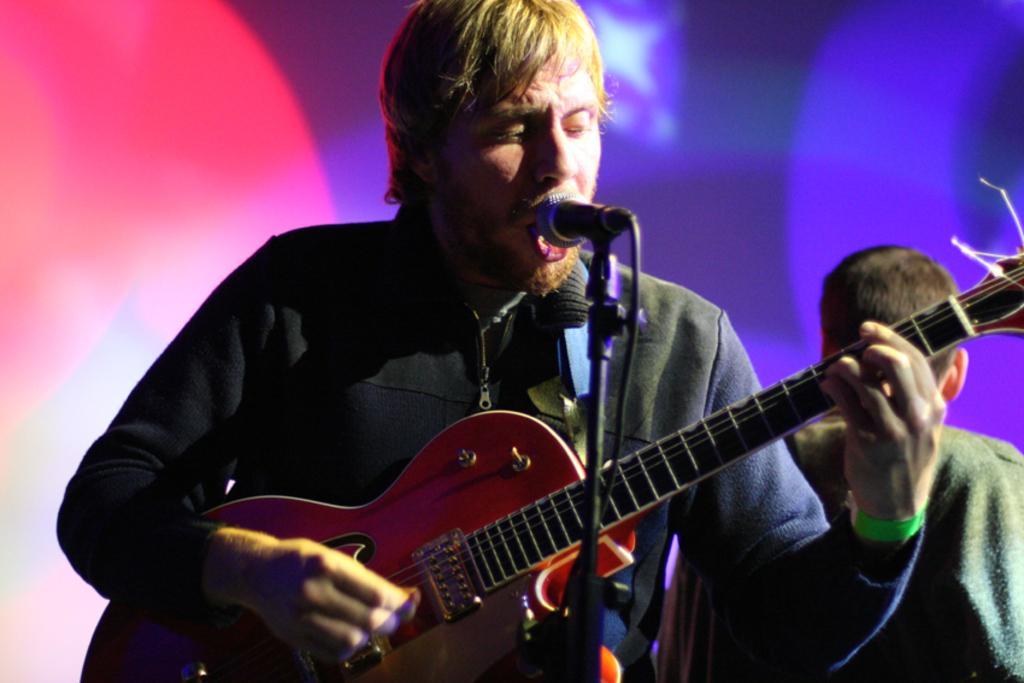Describe this image in one or two sentences. A man is singing. He holds a guitar and has mic in front of him. He wears a black sweatshirt. There is a man behind him and different shades of light. 